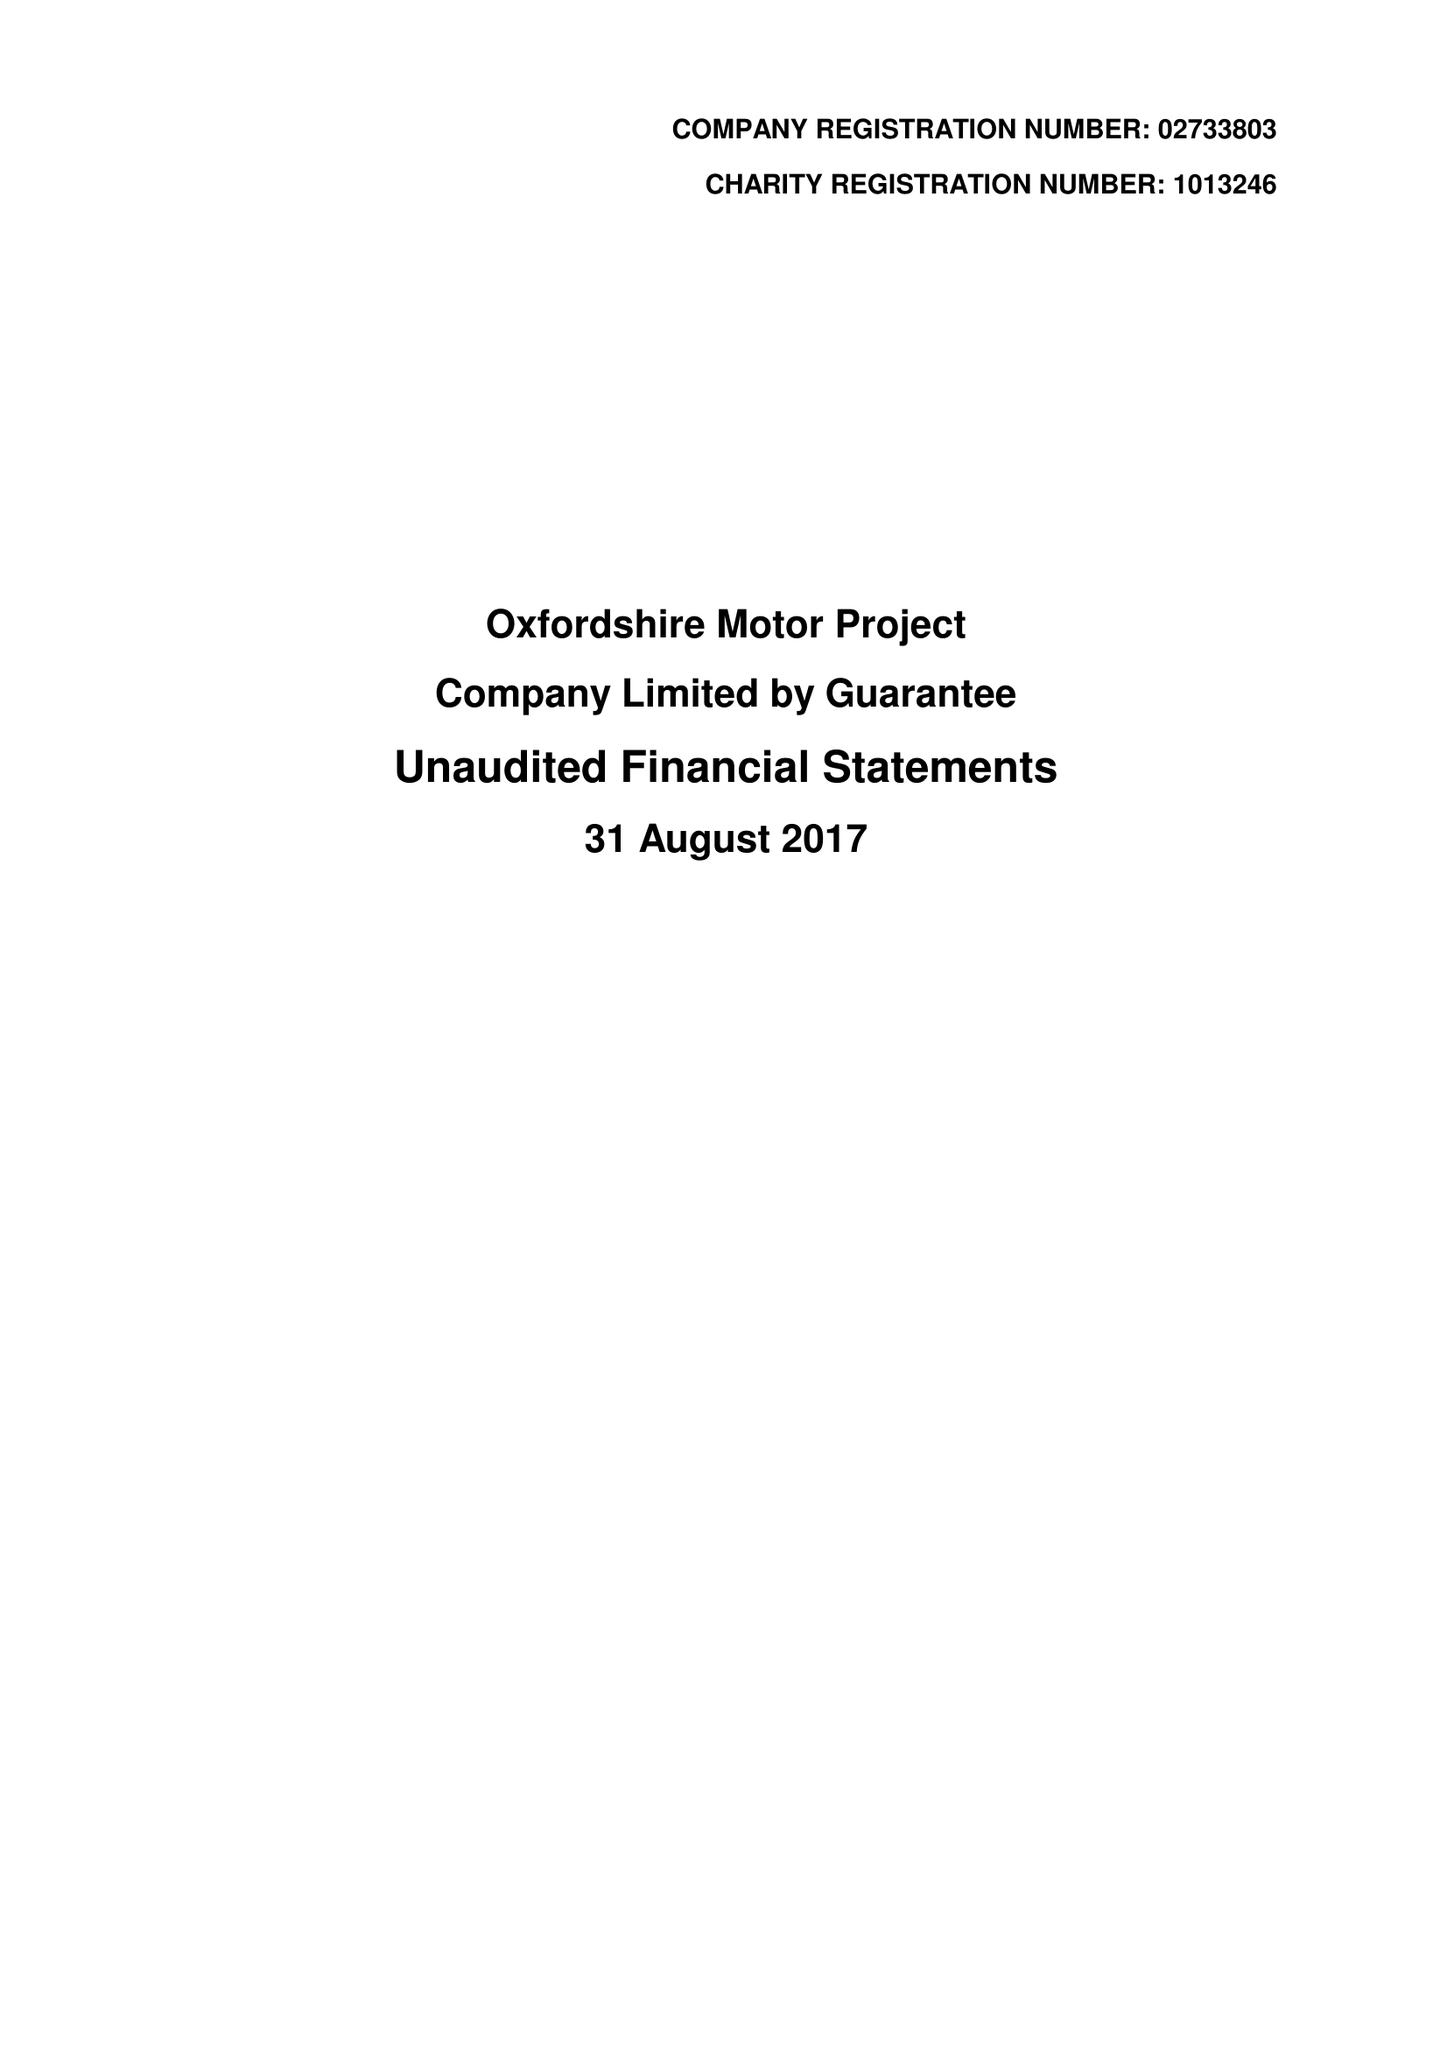What is the value for the address__post_town?
Answer the question using a single word or phrase. OXFORD 